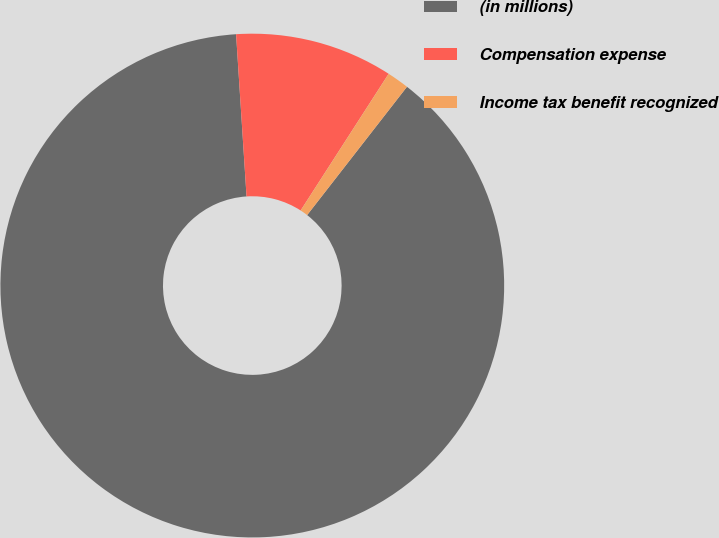Convert chart. <chart><loc_0><loc_0><loc_500><loc_500><pie_chart><fcel>(in millions)<fcel>Compensation expense<fcel>Income tax benefit recognized<nl><fcel>88.45%<fcel>10.13%<fcel>1.42%<nl></chart> 